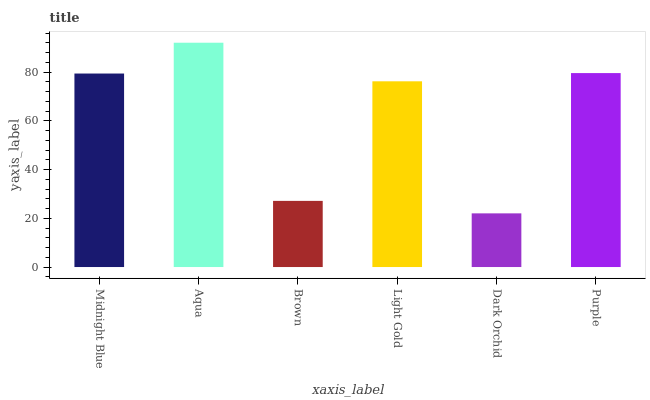Is Dark Orchid the minimum?
Answer yes or no. Yes. Is Aqua the maximum?
Answer yes or no. Yes. Is Brown the minimum?
Answer yes or no. No. Is Brown the maximum?
Answer yes or no. No. Is Aqua greater than Brown?
Answer yes or no. Yes. Is Brown less than Aqua?
Answer yes or no. Yes. Is Brown greater than Aqua?
Answer yes or no. No. Is Aqua less than Brown?
Answer yes or no. No. Is Midnight Blue the high median?
Answer yes or no. Yes. Is Light Gold the low median?
Answer yes or no. Yes. Is Purple the high median?
Answer yes or no. No. Is Dark Orchid the low median?
Answer yes or no. No. 